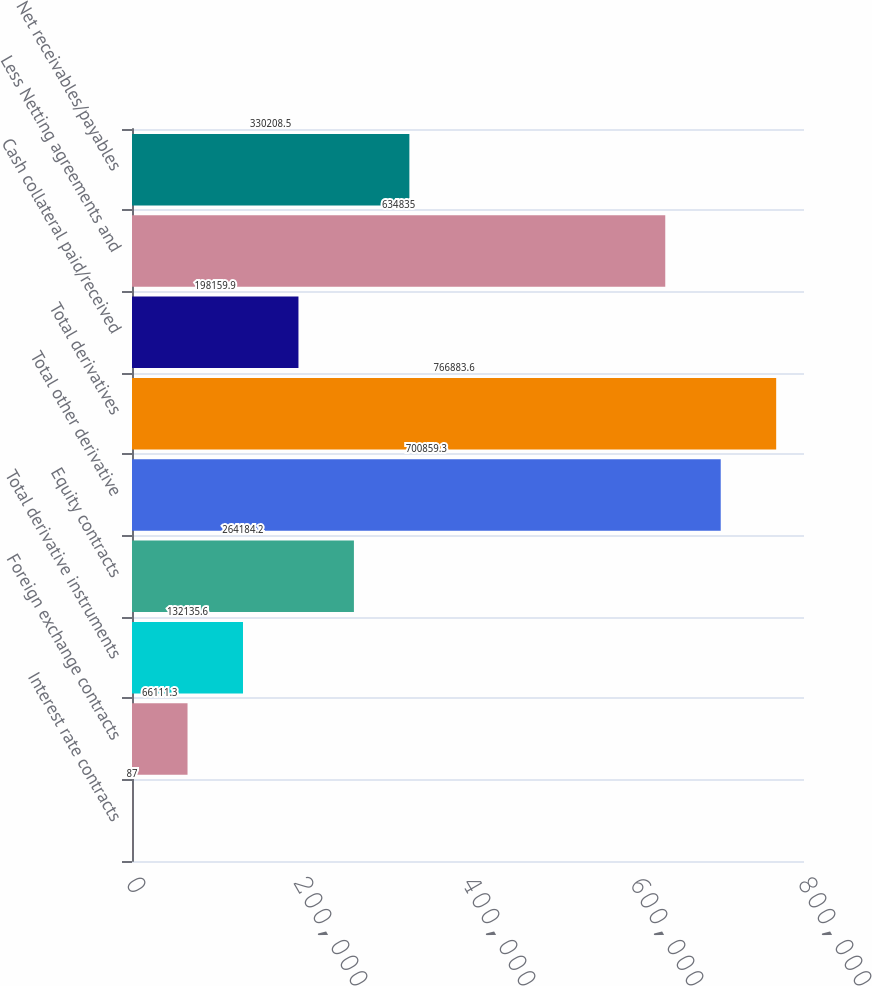<chart> <loc_0><loc_0><loc_500><loc_500><bar_chart><fcel>Interest rate contracts<fcel>Foreign exchange contracts<fcel>Total derivative instruments<fcel>Equity contracts<fcel>Total other derivative<fcel>Total derivatives<fcel>Cash collateral paid/received<fcel>Less Netting agreements and<fcel>Net receivables/payables<nl><fcel>87<fcel>66111.3<fcel>132136<fcel>264184<fcel>700859<fcel>766884<fcel>198160<fcel>634835<fcel>330208<nl></chart> 